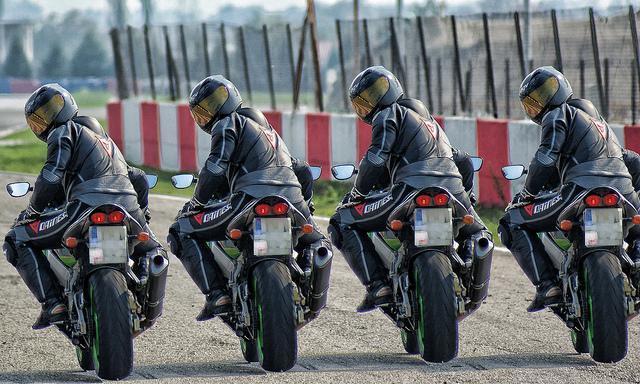What are the motorcycles riding on?
From the following set of four choices, select the accurate answer to respond to the question.
Options: Asphalt, concrete, water, dirt. Asphalt. 